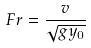<formula> <loc_0><loc_0><loc_500><loc_500>F r = \frac { v } { \sqrt { g y _ { 0 } } }</formula> 